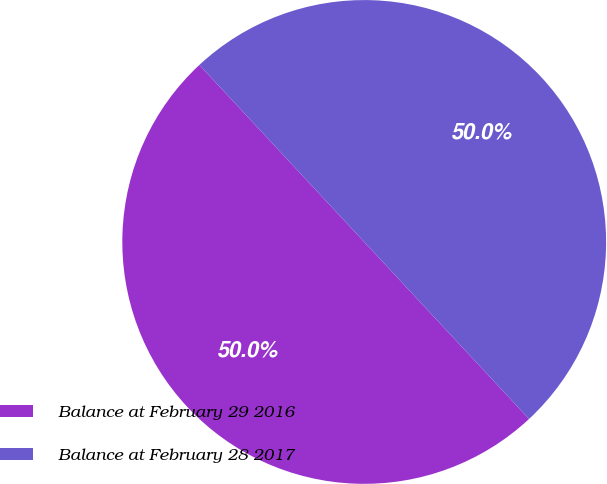Convert chart to OTSL. <chart><loc_0><loc_0><loc_500><loc_500><pie_chart><fcel>Balance at February 29 2016<fcel>Balance at February 28 2017<nl><fcel>50.0%<fcel>50.0%<nl></chart> 